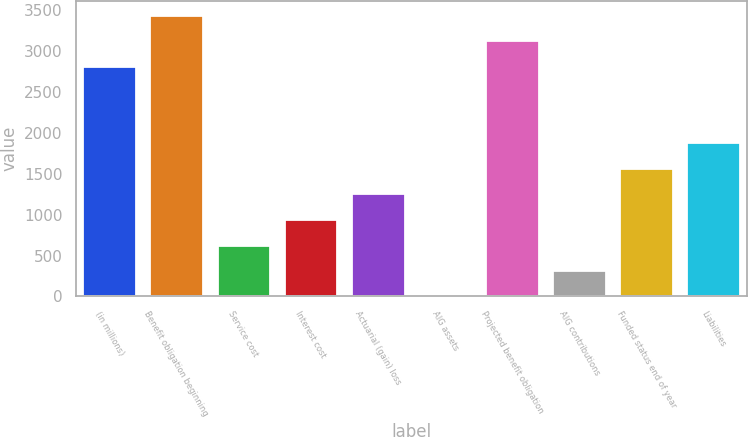Convert chart to OTSL. <chart><loc_0><loc_0><loc_500><loc_500><bar_chart><fcel>(in millions)<fcel>Benefit obligation beginning<fcel>Service cost<fcel>Interest cost<fcel>Actuarial (gain) loss<fcel>AIG assets<fcel>Projected benefit obligation<fcel>AIG contributions<fcel>Funded status end of year<fcel>Liabilities<nl><fcel>2818.9<fcel>3443.1<fcel>634.2<fcel>946.3<fcel>1258.4<fcel>10<fcel>3131<fcel>322.1<fcel>1570.5<fcel>1882.6<nl></chart> 